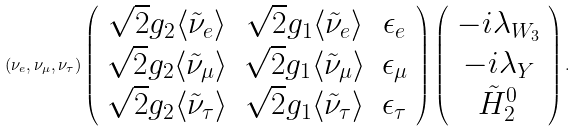<formula> <loc_0><loc_0><loc_500><loc_500>( \nu _ { e } , \nu _ { \mu } , \nu _ { \tau } ) \left ( \begin{array} { c c c } \sqrt { 2 } g _ { 2 } \langle \tilde { \nu } _ { e } \rangle & \sqrt { 2 } g _ { 1 } \langle \tilde { \nu } _ { e } \rangle & \epsilon _ { e } \\ \sqrt { 2 } g _ { 2 } \langle \tilde { \nu } _ { \mu } \rangle & \sqrt { 2 } g _ { 1 } \langle \tilde { \nu } _ { \mu } \rangle & \epsilon _ { \mu } \\ \sqrt { 2 } g _ { 2 } \langle \tilde { \nu } _ { \tau } \rangle & \sqrt { 2 } g _ { 1 } \langle \tilde { \nu } _ { \tau } \rangle & \epsilon _ { \tau } \\ \end{array} \right ) \left ( \begin{array} { c } - i \lambda _ { W _ { 3 } } \\ - i \lambda _ { Y } \\ \tilde { H } _ { 2 } ^ { 0 } \\ \end{array} \right ) .</formula> 